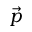Convert formula to latex. <formula><loc_0><loc_0><loc_500><loc_500>\vec { p }</formula> 